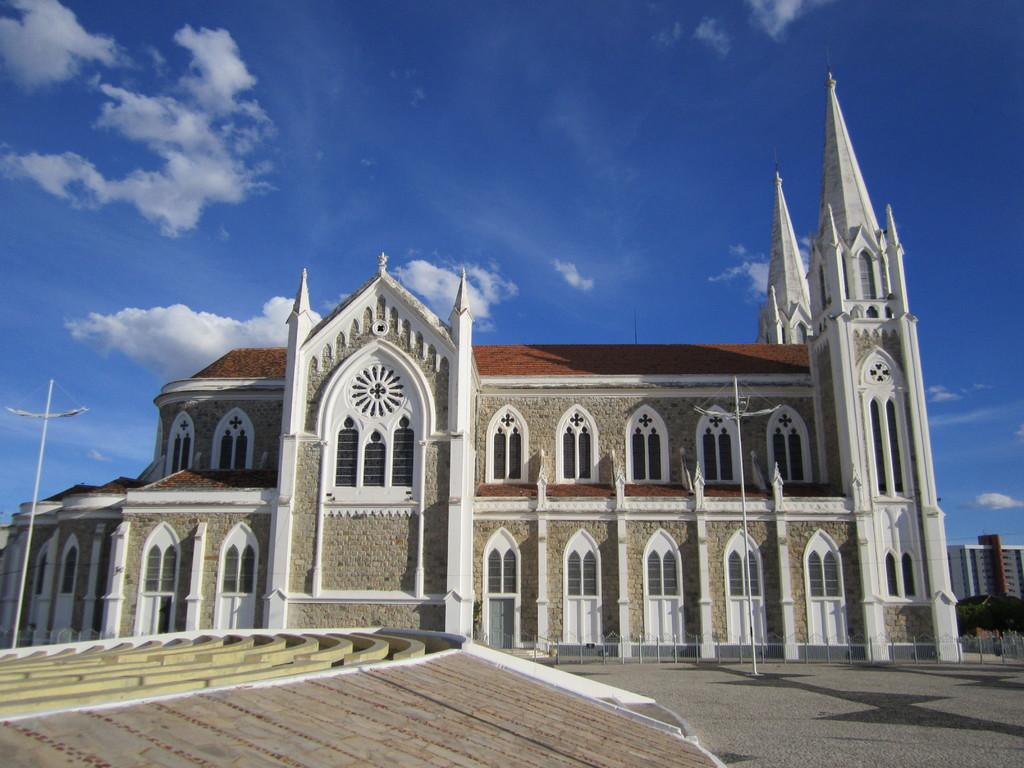Could you give a brief overview of what you see in this image? In this image there is a church building, in front of the church building there are two lamp posts. 